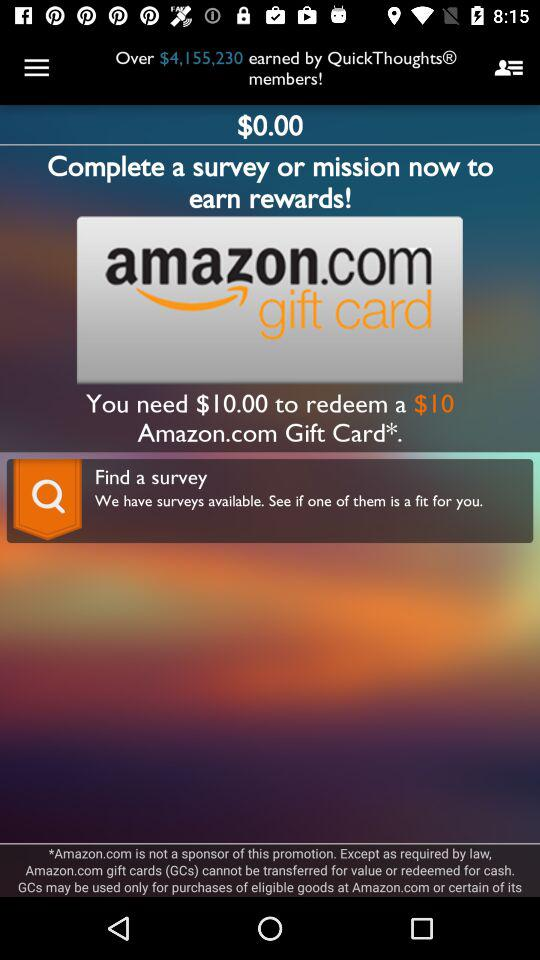How many dollars are needed to redeem the Amazon.com Gift Card? You need 10 dollars to redeem the Amazon.com Gift Card. 